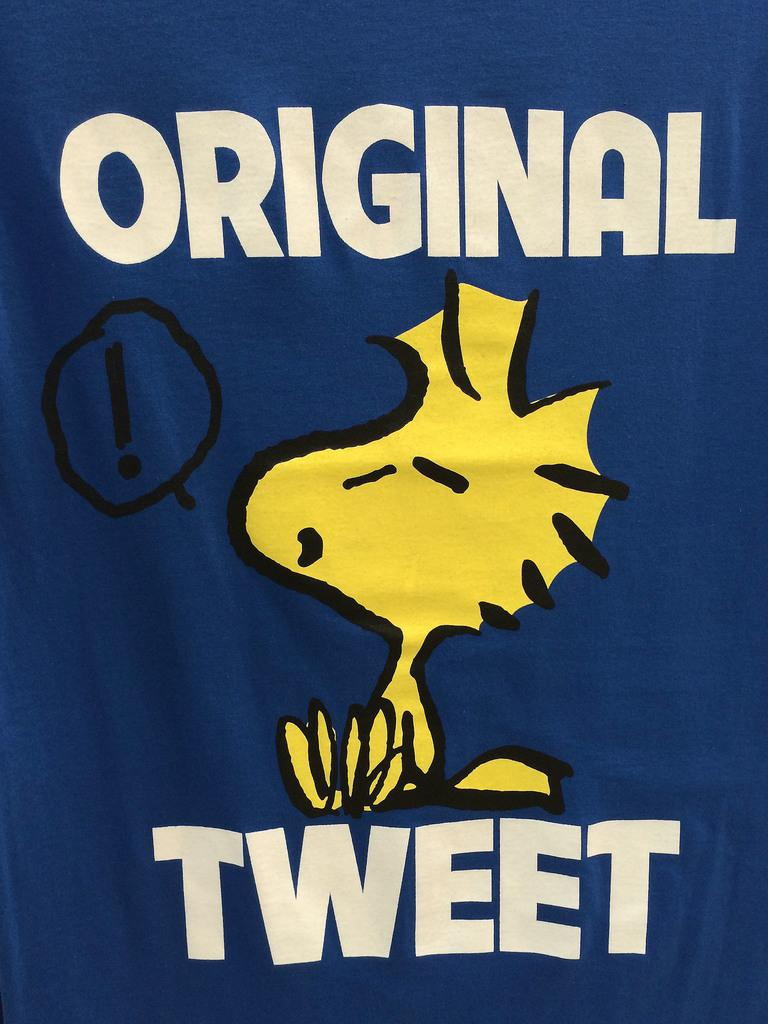What color is the poster in the image? The poster in the image is blue. What text is written on the blue poster? The text "original tweet" is written on the blue poster. What type of picture is present in the image? There is an animated picture in the image. What color is the animated picture? The animated picture is yellow in color. How many slices of pie are on the blue poster? There are no slices of pie present on the blue poster; it only has the text "original tweet." 